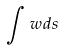Convert formula to latex. <formula><loc_0><loc_0><loc_500><loc_500>\int w d s</formula> 